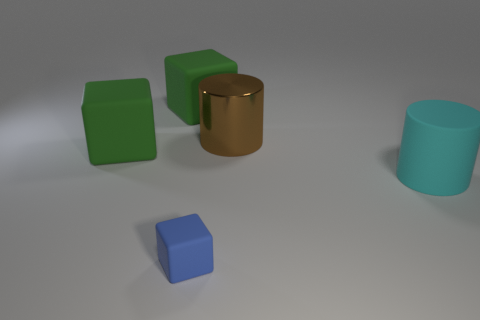Add 5 matte balls. How many objects exist? 10 Subtract all cylinders. How many objects are left? 3 Add 3 big cylinders. How many big cylinders are left? 5 Add 4 big matte objects. How many big matte objects exist? 7 Subtract 0 yellow cylinders. How many objects are left? 5 Subtract all small blue objects. Subtract all cyan rubber objects. How many objects are left? 3 